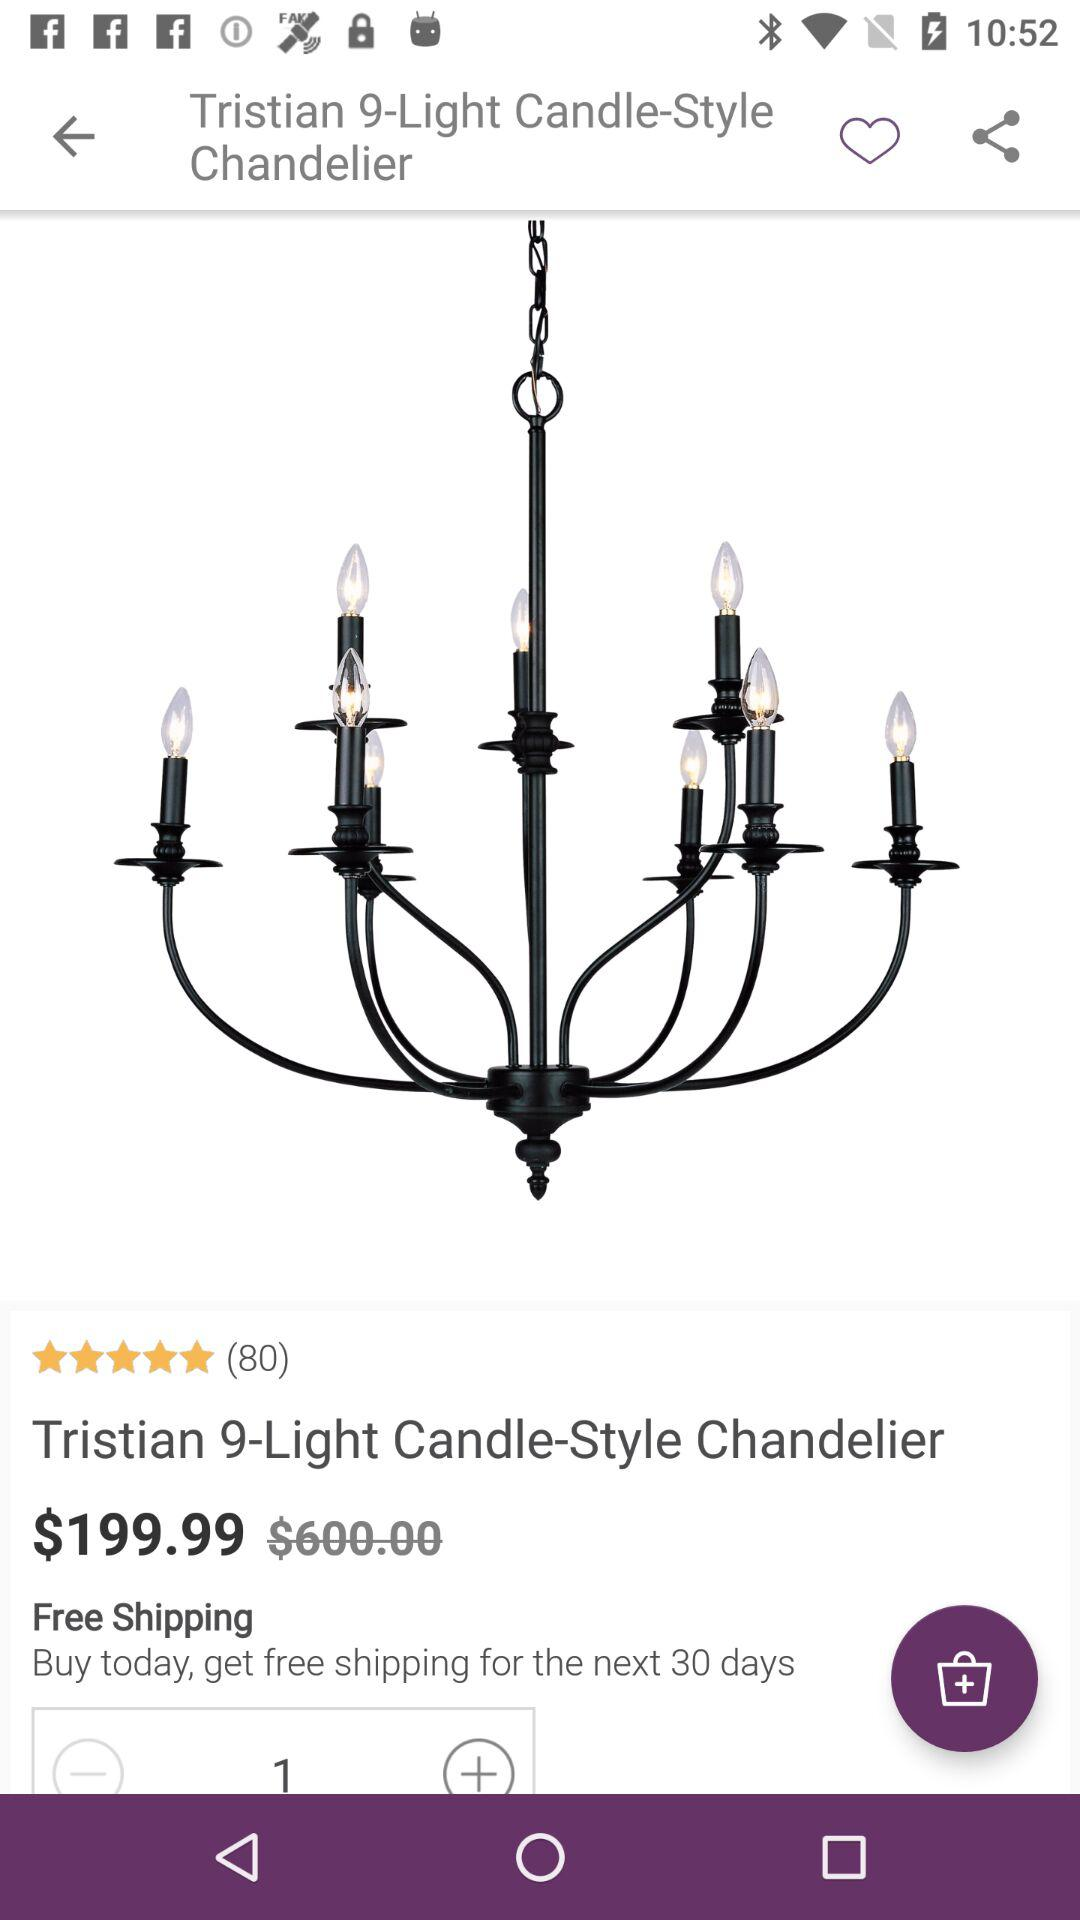What is the price of the product? The price of the product is $199.99. 